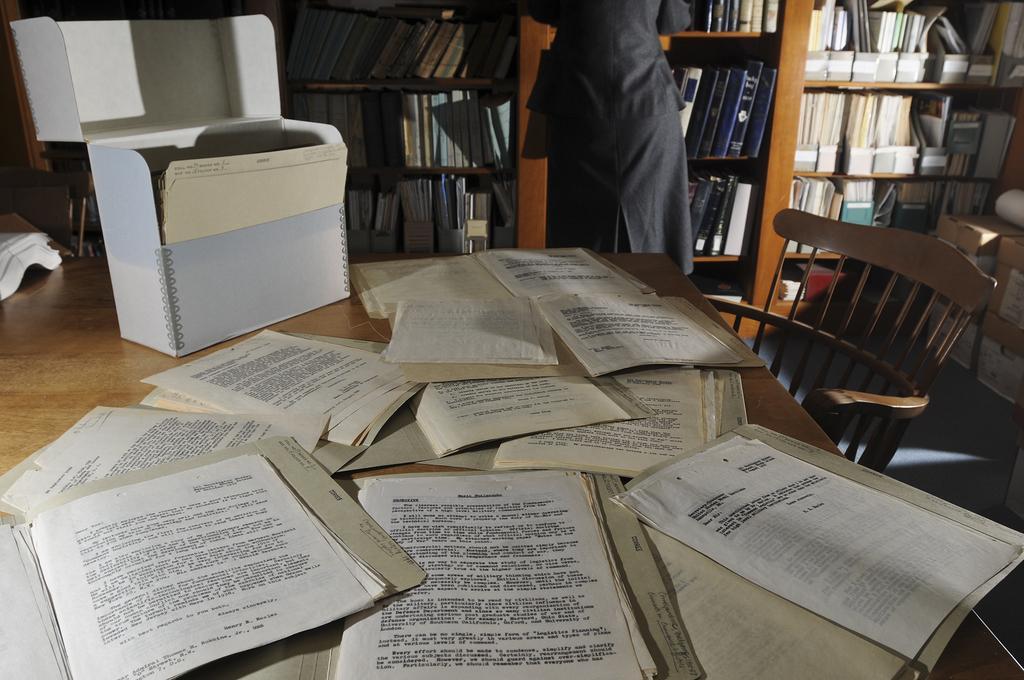Can you describe this image briefly? This picture shows number of papers on the table and a box here. There is a chair in front of the table and a woman is standing in front of a bookshelf here. 